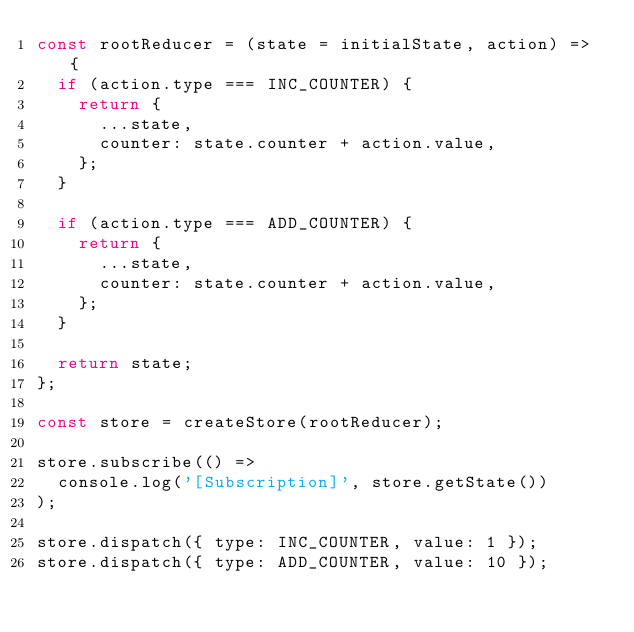Convert code to text. <code><loc_0><loc_0><loc_500><loc_500><_JavaScript_>const rootReducer = (state = initialState, action) => {
  if (action.type === INC_COUNTER) {
    return {
      ...state,
      counter: state.counter + action.value,
    };
  }

  if (action.type === ADD_COUNTER) {
    return {
      ...state,
      counter: state.counter + action.value,
    };
  }

  return state;
};

const store = createStore(rootReducer);

store.subscribe(() =>
  console.log('[Subscription]', store.getState())
);

store.dispatch({ type: INC_COUNTER, value: 1 });
store.dispatch({ type: ADD_COUNTER, value: 10 });
</code> 